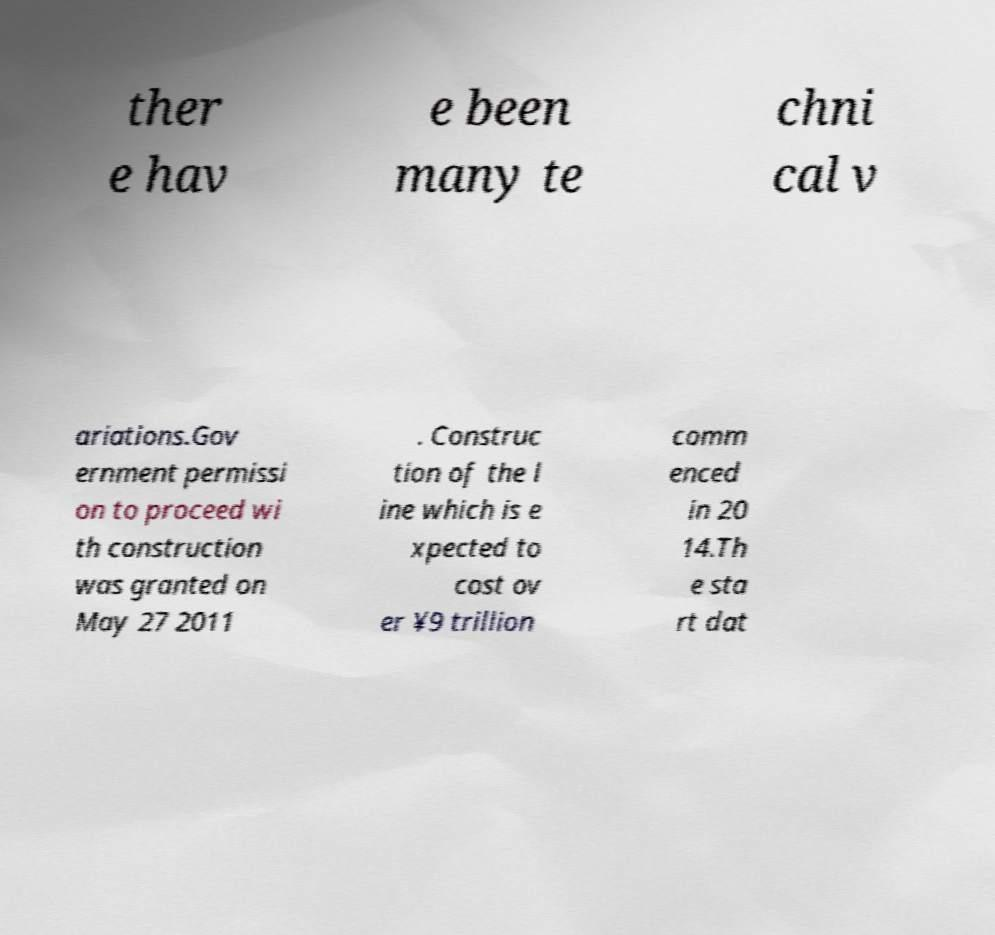Can you read and provide the text displayed in the image?This photo seems to have some interesting text. Can you extract and type it out for me? ther e hav e been many te chni cal v ariations.Gov ernment permissi on to proceed wi th construction was granted on May 27 2011 . Construc tion of the l ine which is e xpected to cost ov er ¥9 trillion comm enced in 20 14.Th e sta rt dat 